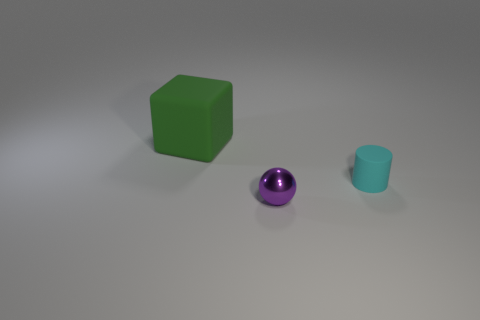There is a thing that is in front of the large rubber thing and behind the small purple ball; what is its size?
Your response must be concise. Small. There is a purple shiny thing that is the same size as the cyan thing; what shape is it?
Your answer should be very brief. Sphere. How big is the shiny thing?
Make the answer very short. Small. There is a object that is in front of the tiny cyan matte object; is its size the same as the matte thing on the right side of the large rubber block?
Ensure brevity in your answer.  Yes. Are there the same number of tiny purple spheres left of the green rubber cube and metal spheres?
Offer a terse response. No. There is a sphere; is its size the same as the rubber thing in front of the big green object?
Provide a succinct answer. Yes. How many blocks are the same material as the tiny cyan object?
Give a very brief answer. 1. Does the cyan cylinder have the same size as the block?
Ensure brevity in your answer.  No. There is a object that is left of the cyan matte cylinder and in front of the big block; what is its shape?
Your response must be concise. Sphere. There is a thing that is on the left side of the tiny purple ball; what is its size?
Your answer should be compact. Large. 